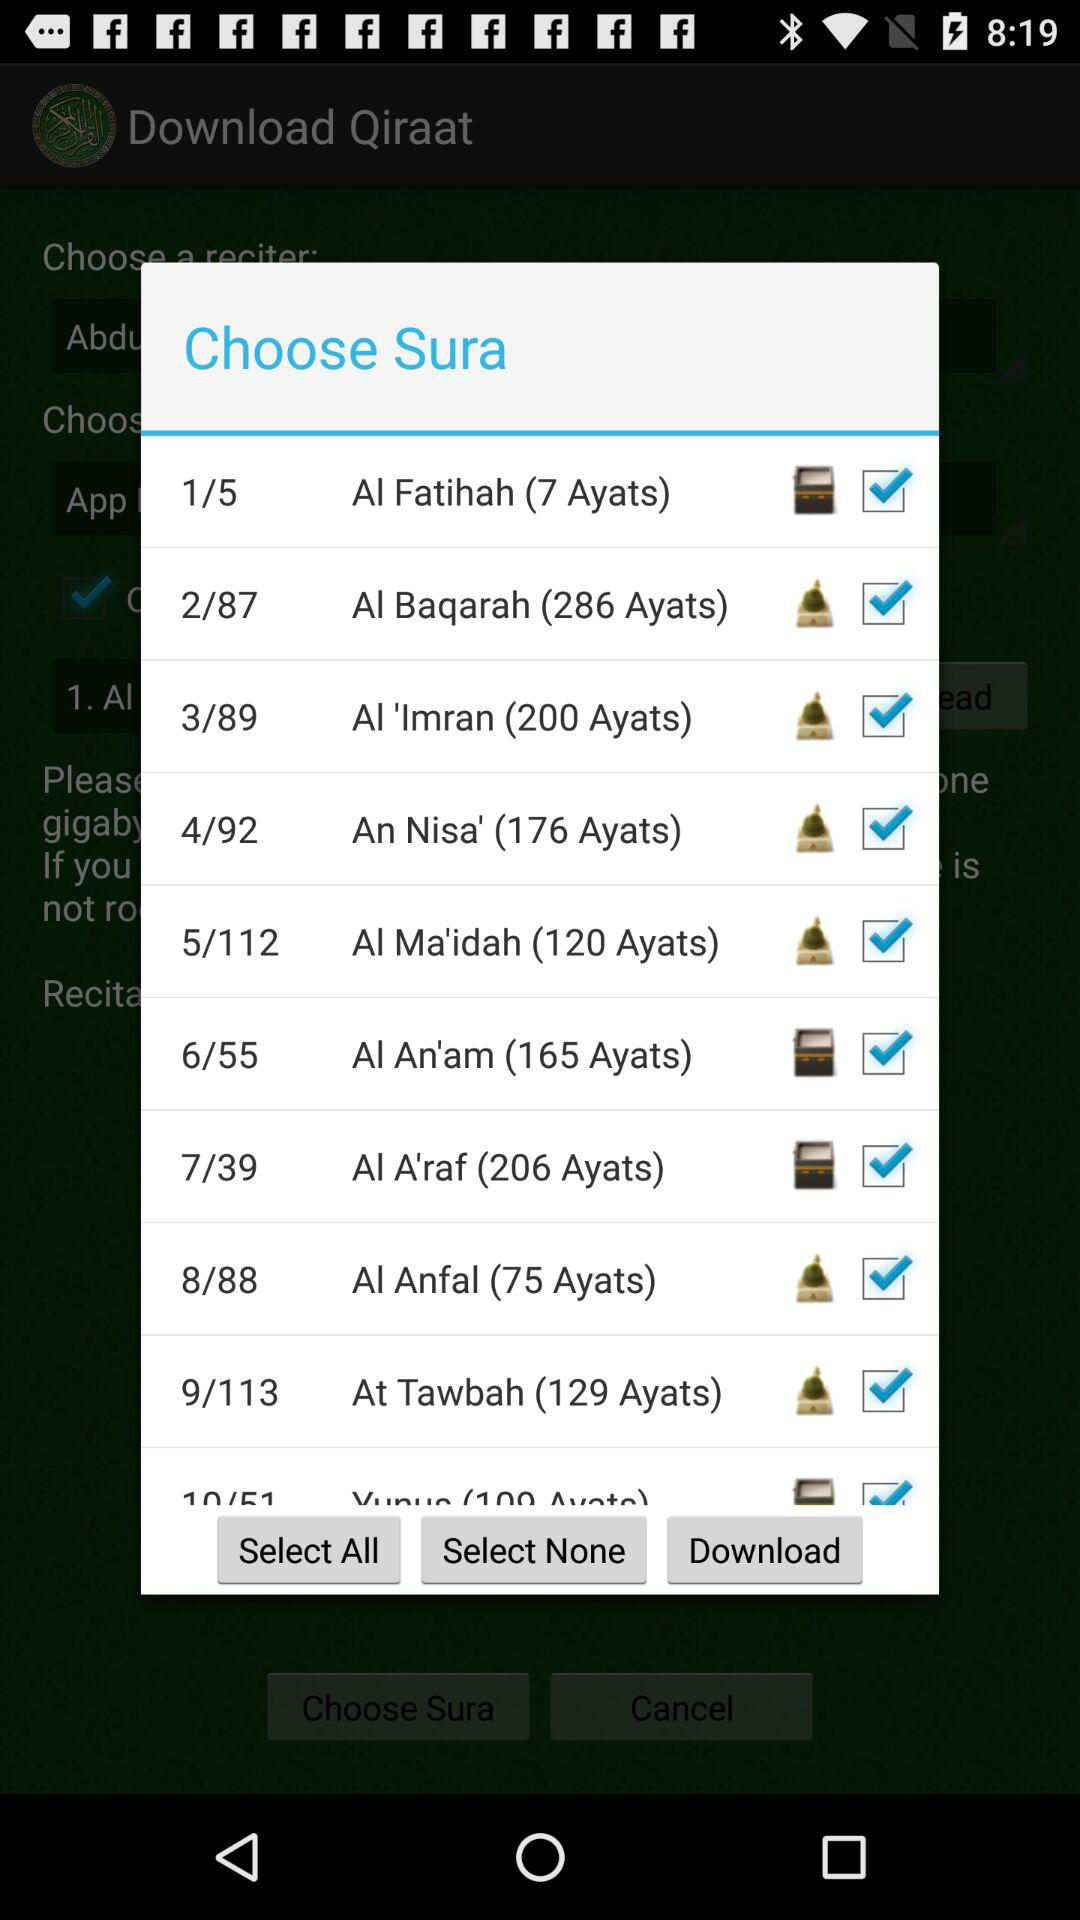How many ayats are in An Nisa?
Answer the question using a single word or phrase. There are 176 Ayats in An Nisa 